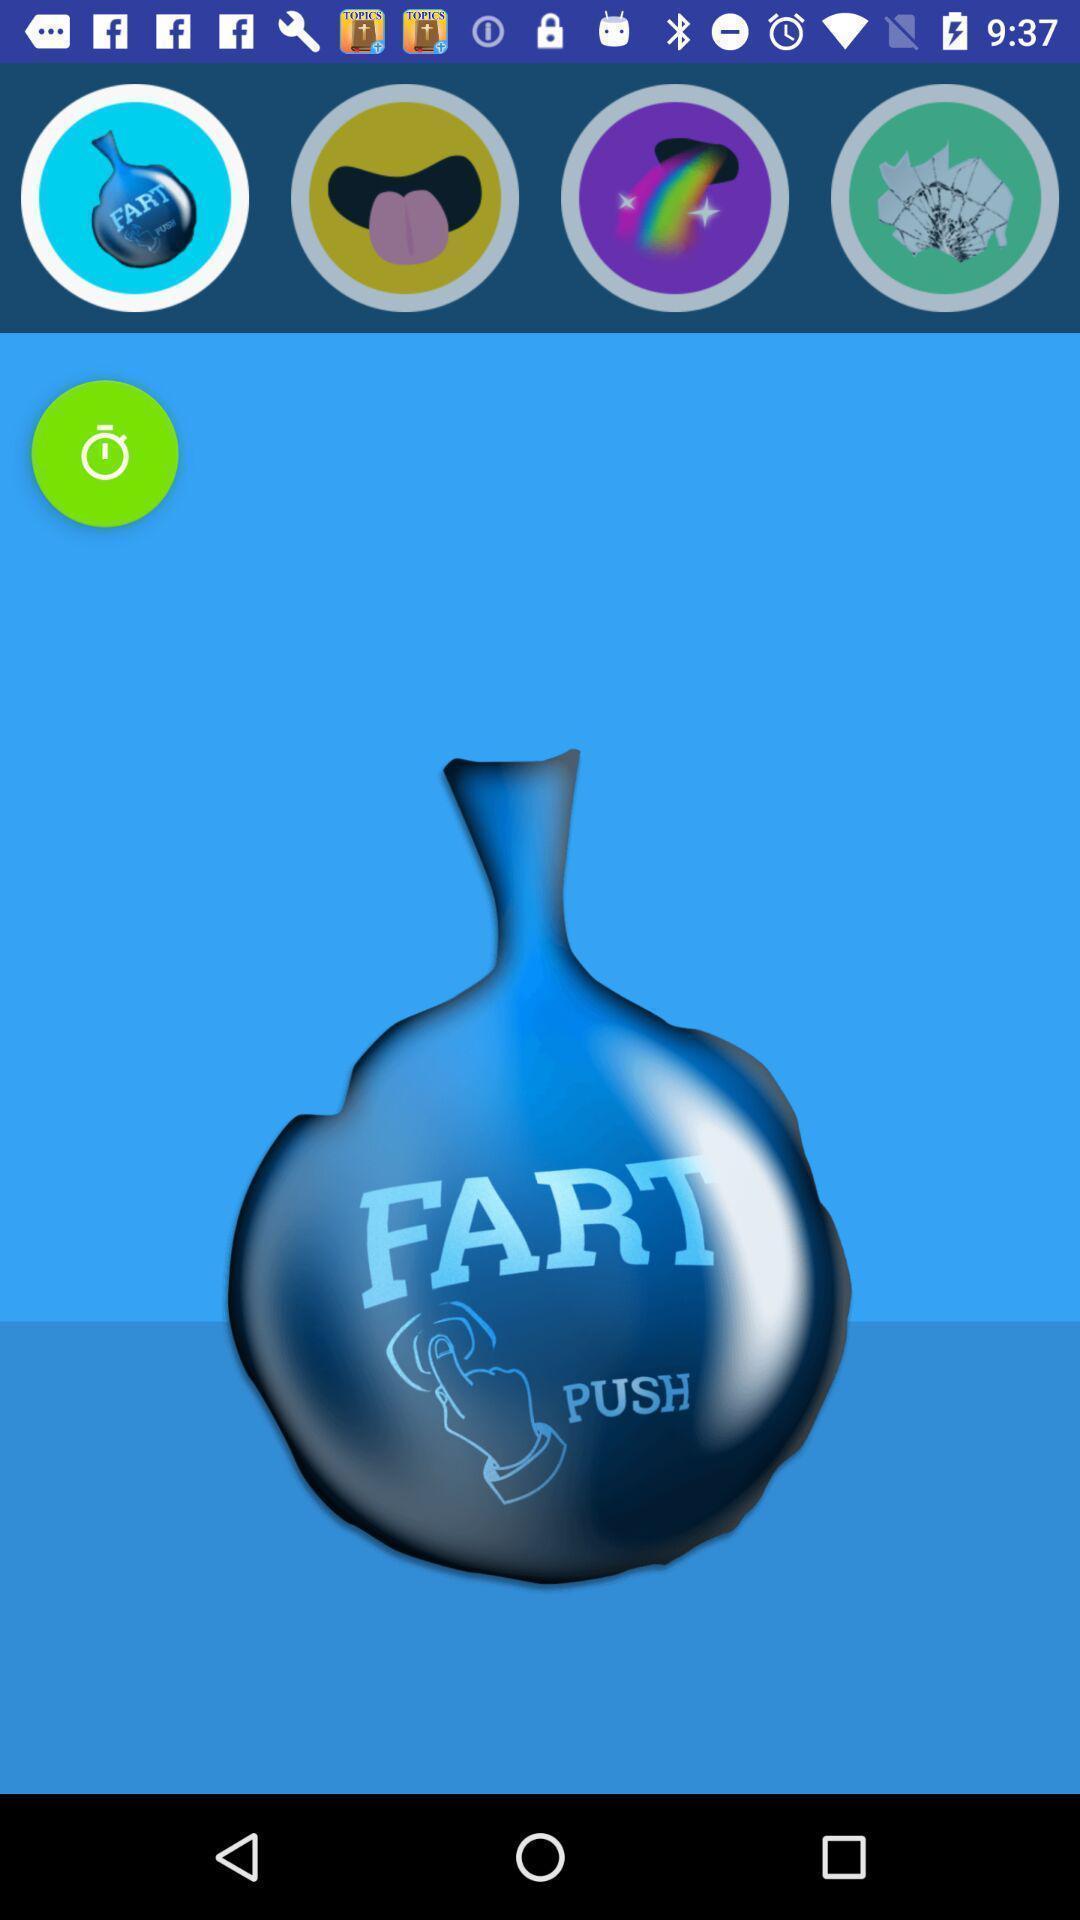Describe this image in words. Screen displaying the various category images. 